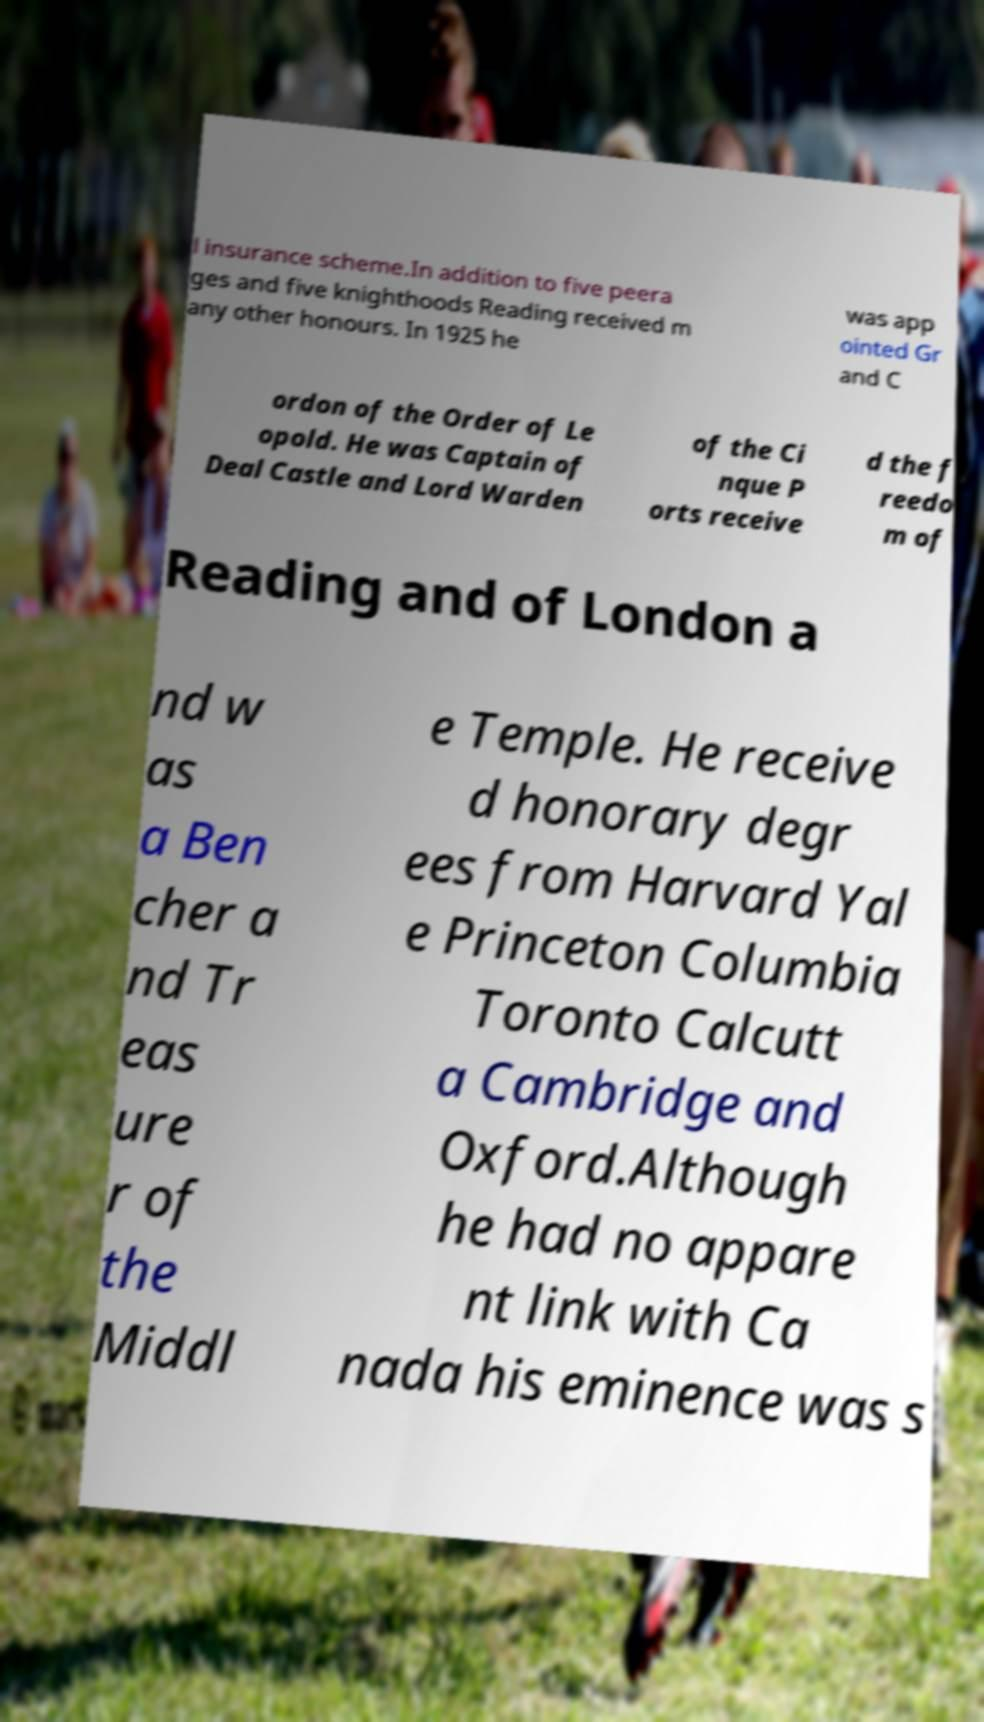Can you accurately transcribe the text from the provided image for me? l insurance scheme.In addition to five peera ges and five knighthoods Reading received m any other honours. In 1925 he was app ointed Gr and C ordon of the Order of Le opold. He was Captain of Deal Castle and Lord Warden of the Ci nque P orts receive d the f reedo m of Reading and of London a nd w as a Ben cher a nd Tr eas ure r of the Middl e Temple. He receive d honorary degr ees from Harvard Yal e Princeton Columbia Toronto Calcutt a Cambridge and Oxford.Although he had no appare nt link with Ca nada his eminence was s 